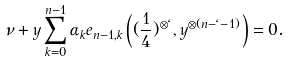<formula> <loc_0><loc_0><loc_500><loc_500>\nu + y \sum _ { k = 0 } ^ { n - 1 } \alpha _ { k } e _ { n - 1 , k } \left ( ( \frac { 1 } { 4 } ) ^ { \otimes \ell } , y ^ { \otimes ( n - \ell - 1 ) } \right ) = 0 .</formula> 